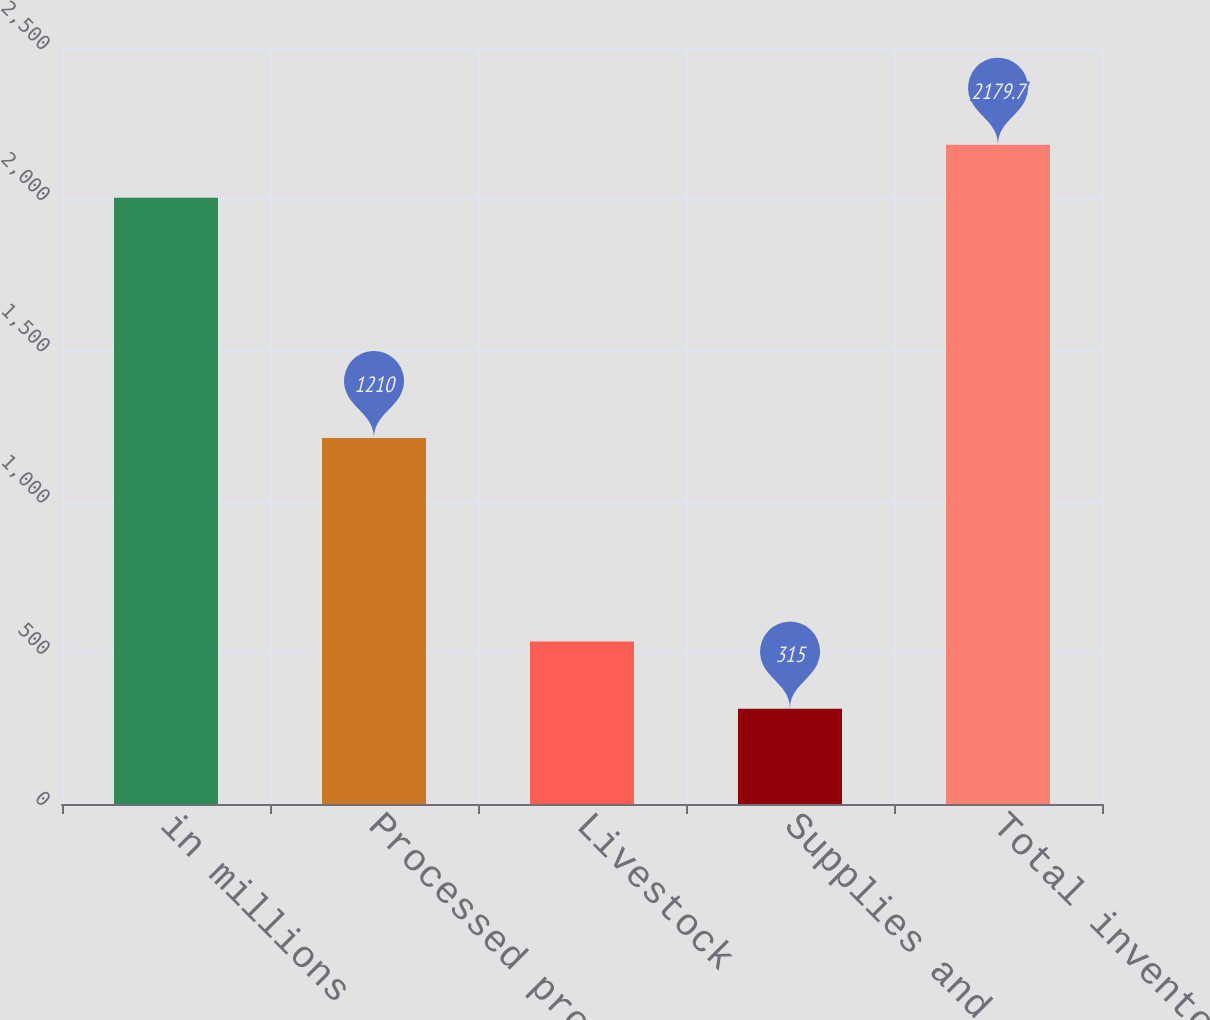Convert chart to OTSL. <chart><loc_0><loc_0><loc_500><loc_500><bar_chart><fcel>in millions<fcel>Processed products<fcel>Livestock<fcel>Supplies and other<fcel>Total inventory<nl><fcel>2005<fcel>1210<fcel>537<fcel>315<fcel>2179.7<nl></chart> 